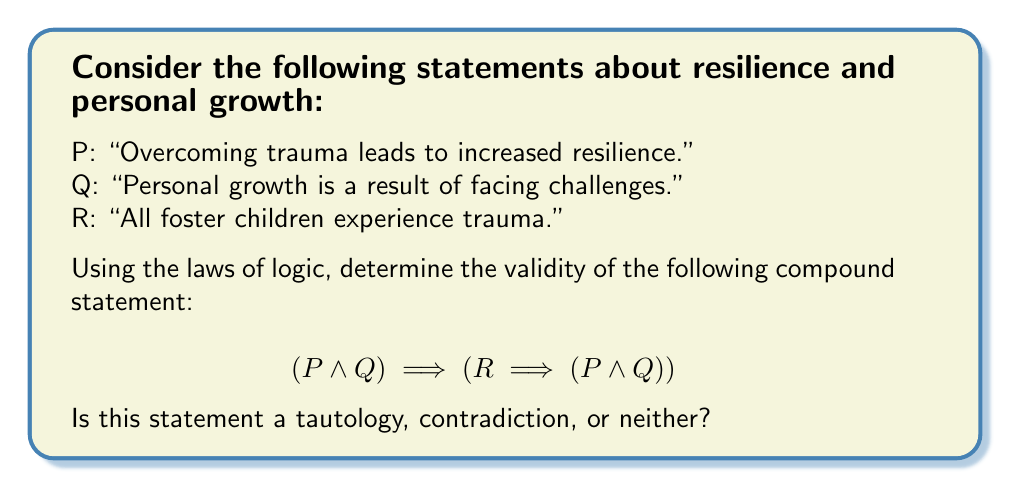Teach me how to tackle this problem. To analyze the logical structure of this statement, we'll use a truth table to evaluate all possible combinations of truth values for P, Q, and R.

1. First, let's break down the compound statement:
   $$(P \land Q) \implies (R \implies (P \land Q))$$

2. We'll evaluate the truth values of the component parts:
   - $(P \land Q)$
   - $R \implies (P \land Q)$
   - The overall implication

3. Create a truth table with 8 rows (2^3 for P, Q, and R):

   | P | Q | R | P ∧ Q | R → (P ∧ Q) | (P ∧ Q) → (R → (P ∧ Q)) |
   |---|---|---|-------|-------------|--------------------------|
   | T | T | T |   T   |      T      |            T             |
   | T | T | F |   T   |      T      |            T             |
   | T | F | T |   F   |      F      |            T             |
   | T | F | F |   F   |      T      |            T             |
   | F | T | T |   F   |      F      |            T             |
   | F | T | F |   F   |      T      |            T             |
   | F | F | T |   F   |      F      |            T             |
   | F | F | F |   F   |      T      |            T             |

4. Analyze the results:
   - The final column shows that the compound statement is true for all possible combinations of P, Q, and R.

5. Interpretation:
   - A statement that is always true, regardless of the truth values of its components, is called a tautology.

This logical analysis demonstrates that the given statement is always true, regardless of the individual truth values of the statements about resilience, personal growth, and foster children's experiences.
Answer: The compound statement $$(P \land Q) \implies (R \implies (P \land Q))$$ is a tautology. 